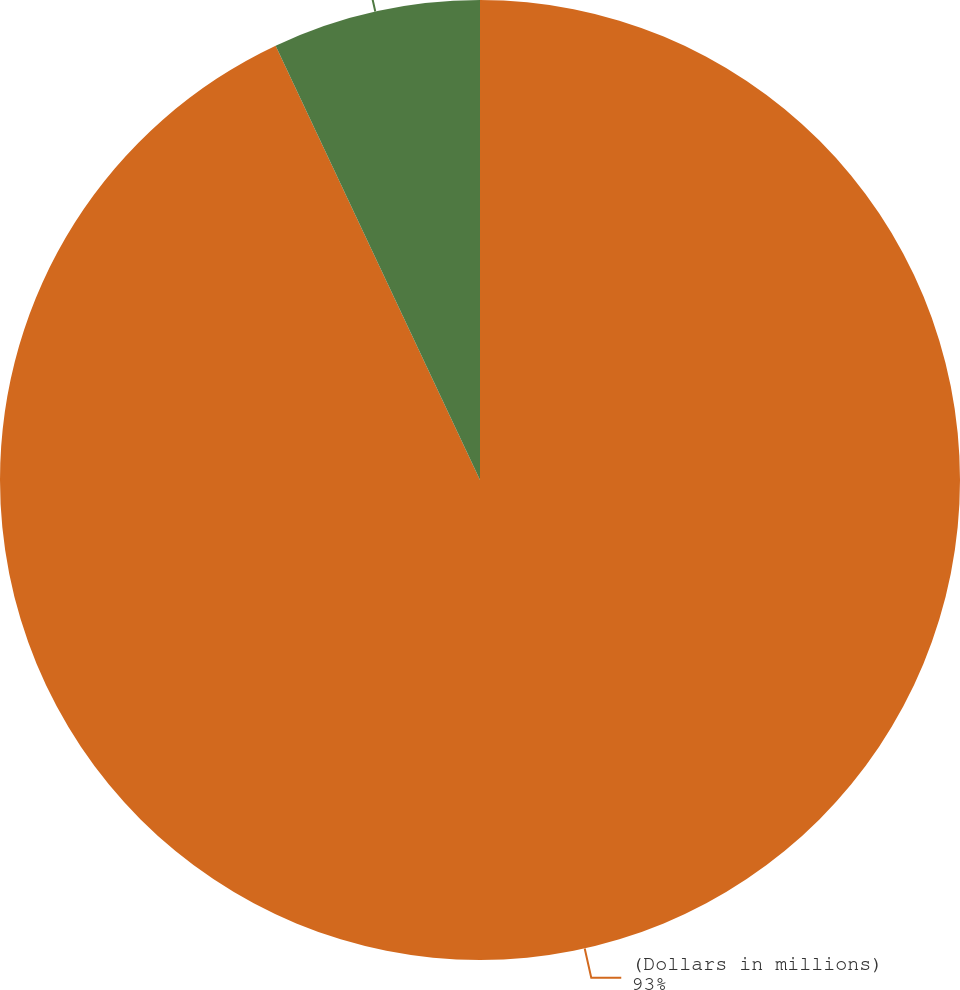Convert chart to OTSL. <chart><loc_0><loc_0><loc_500><loc_500><pie_chart><fcel>(Dollars in millions)<fcel>Cash payments<nl><fcel>93.0%<fcel>7.0%<nl></chart> 